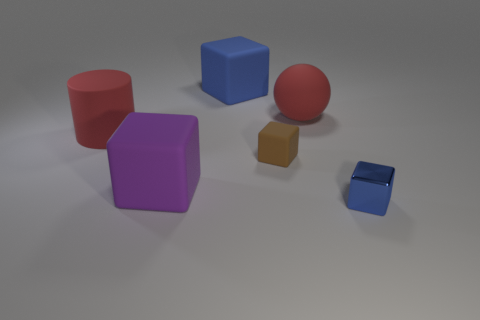Subtract 1 blocks. How many blocks are left? 3 Subtract all blue cubes. Subtract all yellow balls. How many cubes are left? 2 Add 4 cylinders. How many objects exist? 10 Subtract all balls. How many objects are left? 5 Add 4 brown matte blocks. How many brown matte blocks exist? 5 Subtract 0 blue spheres. How many objects are left? 6 Subtract all big blocks. Subtract all small blue things. How many objects are left? 3 Add 1 large purple objects. How many large purple objects are left? 2 